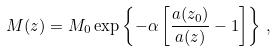<formula> <loc_0><loc_0><loc_500><loc_500>M ( z ) = M _ { 0 } \exp \left \{ - \alpha \left [ \frac { a ( z _ { 0 } ) } { a ( z ) } - 1 \right ] \right \} \, ,</formula> 